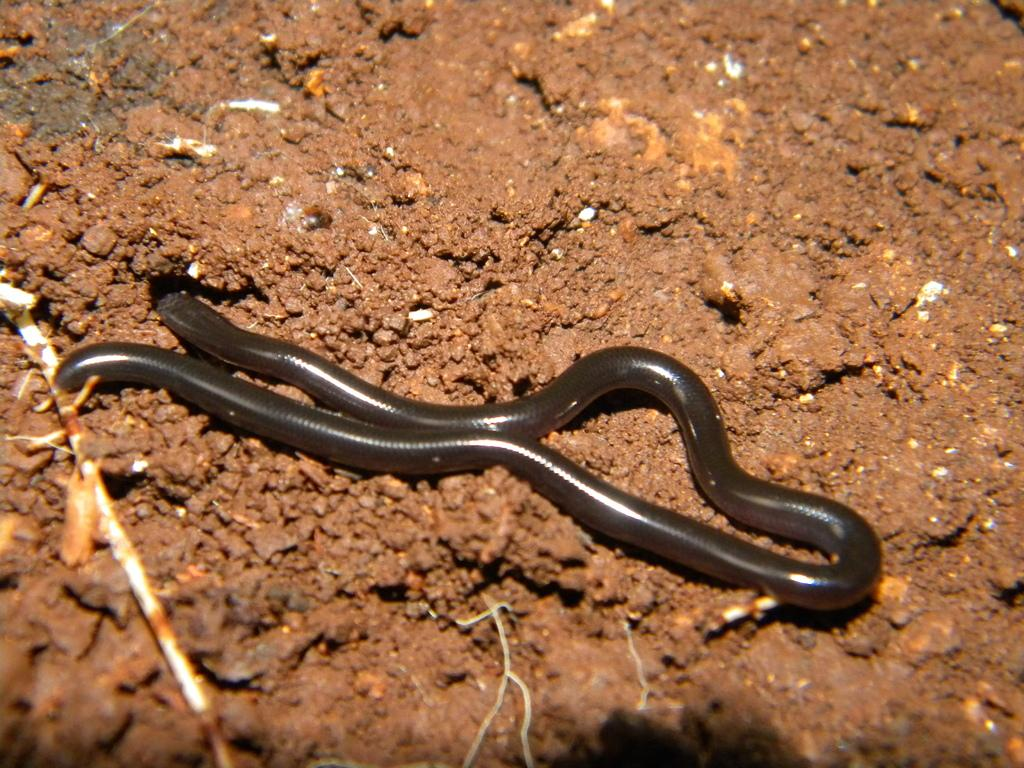What type of animal is in the image? There is a snake in the image. Where is the snake located? The snake is in the soil. What type of creature is the snake thinking about in the image? There is no indication in the image that the snake is thinking about anything, as it is an animal and does not have the ability to think or have thoughts. 